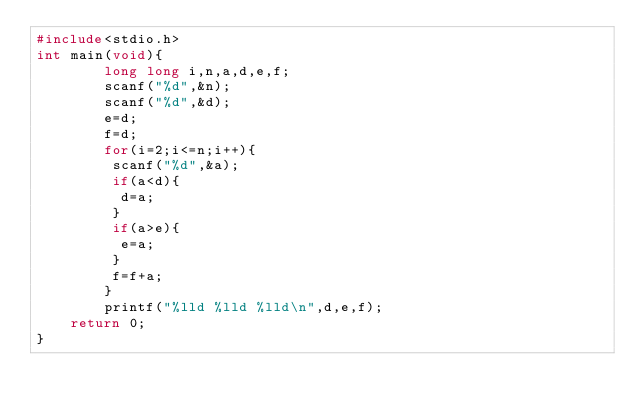<code> <loc_0><loc_0><loc_500><loc_500><_C_>#include<stdio.h>
int main(void){
        long long i,n,a,d,e,f;
        scanf("%d",&n);
        scanf("%d",&d);
        e=d;
        f=d;
        for(i=2;i<=n;i++){
         scanf("%d",&a);
         if(a<d){
          d=a;
         }
         if(a>e){
          e=a;
         }
         f=f+a;
        }
        printf("%lld %lld %lld\n",d,e,f);
    return 0;
}</code> 